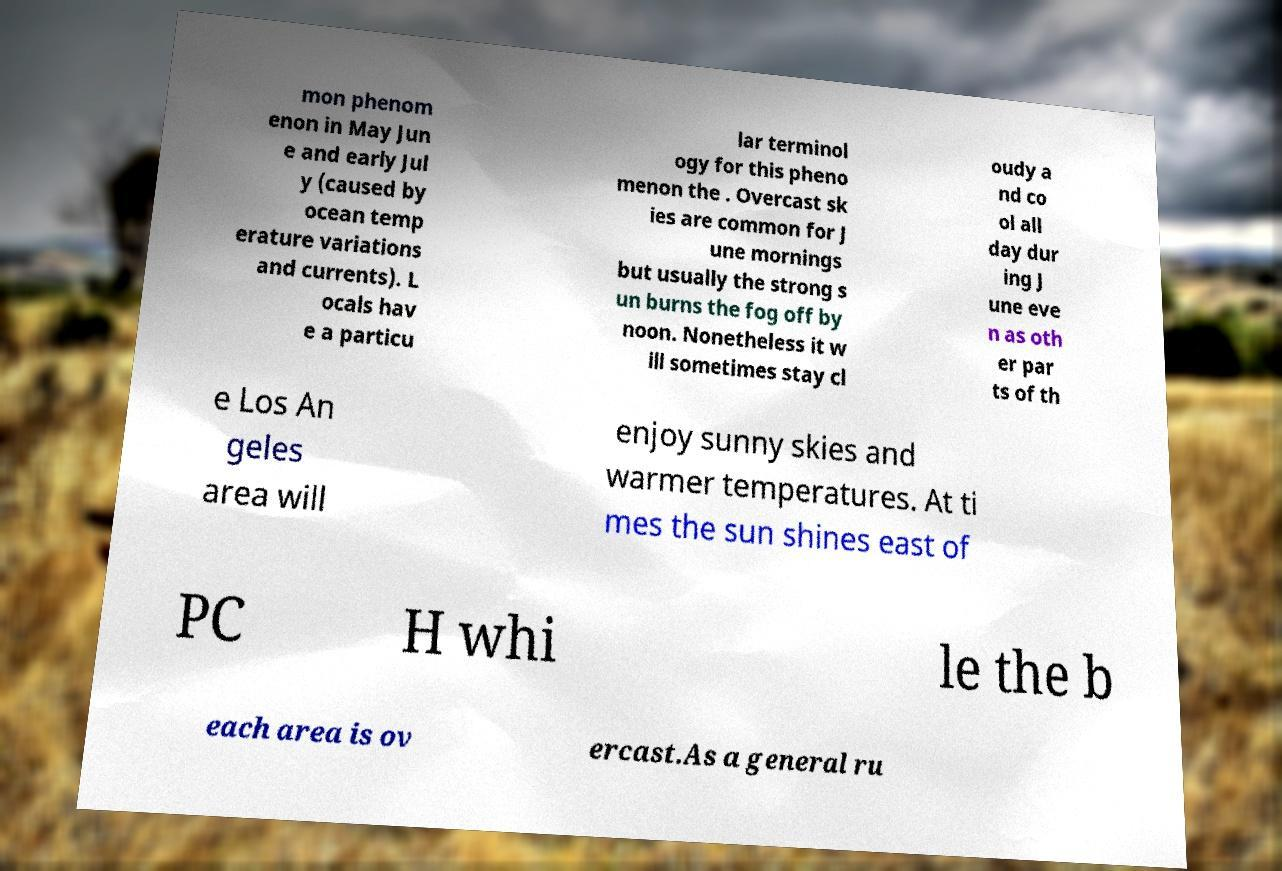Can you accurately transcribe the text from the provided image for me? mon phenom enon in May Jun e and early Jul y (caused by ocean temp erature variations and currents). L ocals hav e a particu lar terminol ogy for this pheno menon the . Overcast sk ies are common for J une mornings but usually the strong s un burns the fog off by noon. Nonetheless it w ill sometimes stay cl oudy a nd co ol all day dur ing J une eve n as oth er par ts of th e Los An geles area will enjoy sunny skies and warmer temperatures. At ti mes the sun shines east of PC H whi le the b each area is ov ercast.As a general ru 